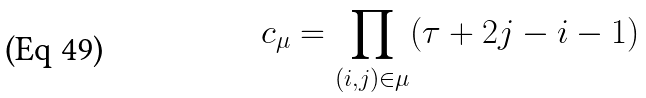Convert formula to latex. <formula><loc_0><loc_0><loc_500><loc_500>c _ { \mu } = \prod _ { ( i , j ) \in \mu } ( \tau + 2 j - i - 1 )</formula> 